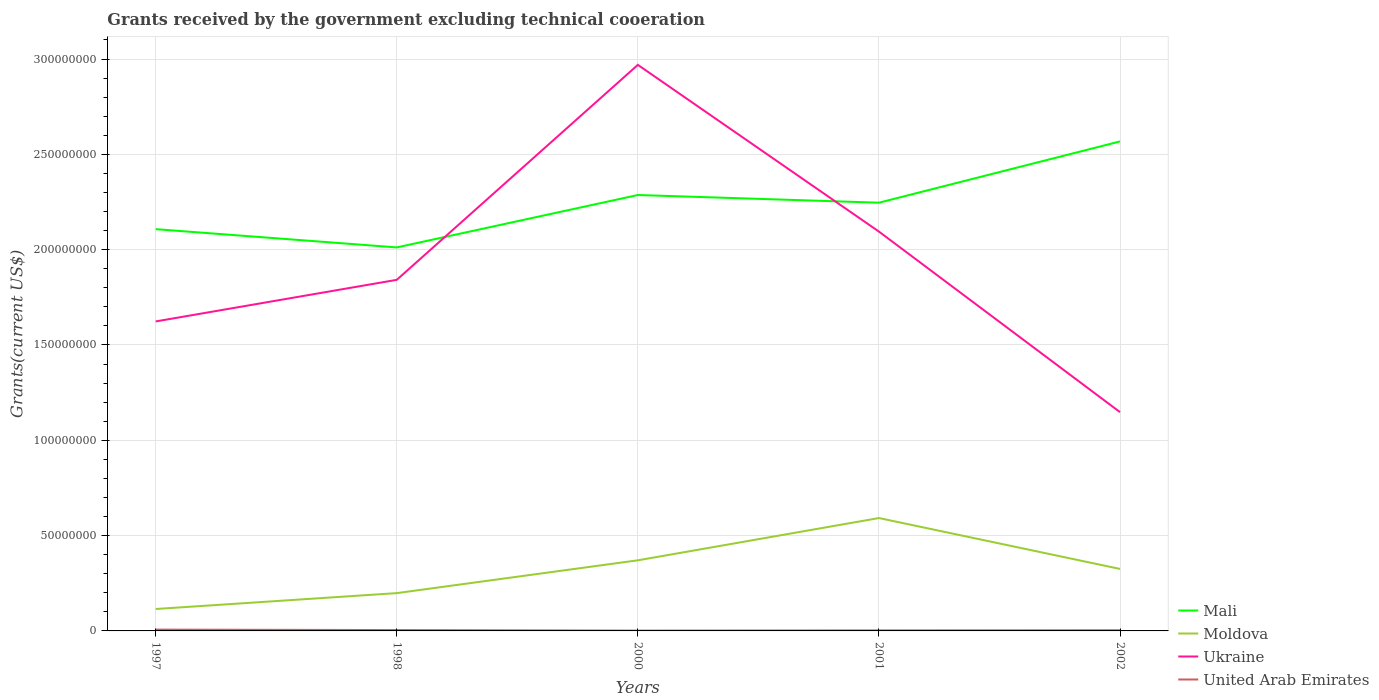Does the line corresponding to Ukraine intersect with the line corresponding to Mali?
Your response must be concise. Yes. Across all years, what is the maximum total grants received by the government in Mali?
Give a very brief answer. 2.01e+08. In which year was the total grants received by the government in Mali maximum?
Give a very brief answer. 1998. What is the total total grants received by the government in United Arab Emirates in the graph?
Your response must be concise. -1.10e+05. What is the difference between the highest and the second highest total grants received by the government in Mali?
Your answer should be compact. 5.56e+07. What is the difference between the highest and the lowest total grants received by the government in Moldova?
Provide a short and direct response. 3. How many years are there in the graph?
Make the answer very short. 5. What is the difference between two consecutive major ticks on the Y-axis?
Provide a succinct answer. 5.00e+07. Are the values on the major ticks of Y-axis written in scientific E-notation?
Provide a short and direct response. No. How many legend labels are there?
Your response must be concise. 4. What is the title of the graph?
Ensure brevity in your answer.  Grants received by the government excluding technical cooeration. What is the label or title of the X-axis?
Ensure brevity in your answer.  Years. What is the label or title of the Y-axis?
Make the answer very short. Grants(current US$). What is the Grants(current US$) of Mali in 1997?
Your answer should be very brief. 2.11e+08. What is the Grants(current US$) of Moldova in 1997?
Ensure brevity in your answer.  1.15e+07. What is the Grants(current US$) of Ukraine in 1997?
Make the answer very short. 1.62e+08. What is the Grants(current US$) of United Arab Emirates in 1997?
Keep it short and to the point. 6.90e+05. What is the Grants(current US$) of Mali in 1998?
Keep it short and to the point. 2.01e+08. What is the Grants(current US$) in Moldova in 1998?
Your answer should be compact. 1.98e+07. What is the Grants(current US$) of Ukraine in 1998?
Make the answer very short. 1.84e+08. What is the Grants(current US$) in Mali in 2000?
Provide a short and direct response. 2.29e+08. What is the Grants(current US$) in Moldova in 2000?
Ensure brevity in your answer.  3.70e+07. What is the Grants(current US$) of Ukraine in 2000?
Make the answer very short. 2.97e+08. What is the Grants(current US$) in Mali in 2001?
Your answer should be compact. 2.25e+08. What is the Grants(current US$) in Moldova in 2001?
Ensure brevity in your answer.  5.92e+07. What is the Grants(current US$) of Ukraine in 2001?
Your response must be concise. 2.09e+08. What is the Grants(current US$) of United Arab Emirates in 2001?
Keep it short and to the point. 2.80e+05. What is the Grants(current US$) of Mali in 2002?
Offer a very short reply. 2.57e+08. What is the Grants(current US$) in Moldova in 2002?
Make the answer very short. 3.25e+07. What is the Grants(current US$) in Ukraine in 2002?
Your answer should be very brief. 1.15e+08. Across all years, what is the maximum Grants(current US$) in Mali?
Provide a short and direct response. 2.57e+08. Across all years, what is the maximum Grants(current US$) of Moldova?
Give a very brief answer. 5.92e+07. Across all years, what is the maximum Grants(current US$) of Ukraine?
Your response must be concise. 2.97e+08. Across all years, what is the maximum Grants(current US$) of United Arab Emirates?
Keep it short and to the point. 6.90e+05. Across all years, what is the minimum Grants(current US$) in Mali?
Keep it short and to the point. 2.01e+08. Across all years, what is the minimum Grants(current US$) of Moldova?
Offer a terse response. 1.15e+07. Across all years, what is the minimum Grants(current US$) of Ukraine?
Offer a very short reply. 1.15e+08. What is the total Grants(current US$) in Mali in the graph?
Your response must be concise. 1.12e+09. What is the total Grants(current US$) of Moldova in the graph?
Ensure brevity in your answer.  1.60e+08. What is the total Grants(current US$) in Ukraine in the graph?
Make the answer very short. 9.68e+08. What is the total Grants(current US$) in United Arab Emirates in the graph?
Provide a short and direct response. 1.95e+06. What is the difference between the Grants(current US$) of Mali in 1997 and that in 1998?
Ensure brevity in your answer.  9.58e+06. What is the difference between the Grants(current US$) in Moldova in 1997 and that in 1998?
Provide a succinct answer. -8.33e+06. What is the difference between the Grants(current US$) of Ukraine in 1997 and that in 1998?
Your response must be concise. -2.18e+07. What is the difference between the Grants(current US$) of United Arab Emirates in 1997 and that in 1998?
Your answer should be very brief. 2.40e+05. What is the difference between the Grants(current US$) in Mali in 1997 and that in 2000?
Your answer should be very brief. -1.79e+07. What is the difference between the Grants(current US$) in Moldova in 1997 and that in 2000?
Offer a terse response. -2.55e+07. What is the difference between the Grants(current US$) in Ukraine in 1997 and that in 2000?
Make the answer very short. -1.35e+08. What is the difference between the Grants(current US$) of United Arab Emirates in 1997 and that in 2000?
Your answer should be compact. 5.20e+05. What is the difference between the Grants(current US$) of Mali in 1997 and that in 2001?
Provide a short and direct response. -1.39e+07. What is the difference between the Grants(current US$) in Moldova in 1997 and that in 2001?
Keep it short and to the point. -4.77e+07. What is the difference between the Grants(current US$) of Ukraine in 1997 and that in 2001?
Your answer should be compact. -4.71e+07. What is the difference between the Grants(current US$) in Mali in 1997 and that in 2002?
Keep it short and to the point. -4.60e+07. What is the difference between the Grants(current US$) in Moldova in 1997 and that in 2002?
Your response must be concise. -2.10e+07. What is the difference between the Grants(current US$) of Ukraine in 1997 and that in 2002?
Provide a short and direct response. 4.76e+07. What is the difference between the Grants(current US$) of Mali in 1998 and that in 2000?
Keep it short and to the point. -2.75e+07. What is the difference between the Grants(current US$) in Moldova in 1998 and that in 2000?
Keep it short and to the point. -1.72e+07. What is the difference between the Grants(current US$) of Ukraine in 1998 and that in 2000?
Keep it short and to the point. -1.13e+08. What is the difference between the Grants(current US$) in Mali in 1998 and that in 2001?
Provide a succinct answer. -2.35e+07. What is the difference between the Grants(current US$) of Moldova in 1998 and that in 2001?
Provide a short and direct response. -3.94e+07. What is the difference between the Grants(current US$) of Ukraine in 1998 and that in 2001?
Give a very brief answer. -2.53e+07. What is the difference between the Grants(current US$) of United Arab Emirates in 1998 and that in 2001?
Provide a succinct answer. 1.70e+05. What is the difference between the Grants(current US$) in Mali in 1998 and that in 2002?
Your answer should be compact. -5.56e+07. What is the difference between the Grants(current US$) of Moldova in 1998 and that in 2002?
Ensure brevity in your answer.  -1.27e+07. What is the difference between the Grants(current US$) in Ukraine in 1998 and that in 2002?
Your answer should be very brief. 6.94e+07. What is the difference between the Grants(current US$) in United Arab Emirates in 1998 and that in 2002?
Your response must be concise. 9.00e+04. What is the difference between the Grants(current US$) in Mali in 2000 and that in 2001?
Give a very brief answer. 4.03e+06. What is the difference between the Grants(current US$) of Moldova in 2000 and that in 2001?
Make the answer very short. -2.22e+07. What is the difference between the Grants(current US$) in Ukraine in 2000 and that in 2001?
Make the answer very short. 8.75e+07. What is the difference between the Grants(current US$) in Mali in 2000 and that in 2002?
Your response must be concise. -2.81e+07. What is the difference between the Grants(current US$) of Moldova in 2000 and that in 2002?
Offer a very short reply. 4.52e+06. What is the difference between the Grants(current US$) of Ukraine in 2000 and that in 2002?
Ensure brevity in your answer.  1.82e+08. What is the difference between the Grants(current US$) of Mali in 2001 and that in 2002?
Your answer should be compact. -3.21e+07. What is the difference between the Grants(current US$) in Moldova in 2001 and that in 2002?
Make the answer very short. 2.67e+07. What is the difference between the Grants(current US$) in Ukraine in 2001 and that in 2002?
Ensure brevity in your answer.  9.47e+07. What is the difference between the Grants(current US$) of United Arab Emirates in 2001 and that in 2002?
Provide a succinct answer. -8.00e+04. What is the difference between the Grants(current US$) in Mali in 1997 and the Grants(current US$) in Moldova in 1998?
Give a very brief answer. 1.91e+08. What is the difference between the Grants(current US$) of Mali in 1997 and the Grants(current US$) of Ukraine in 1998?
Offer a terse response. 2.66e+07. What is the difference between the Grants(current US$) of Mali in 1997 and the Grants(current US$) of United Arab Emirates in 1998?
Your answer should be very brief. 2.10e+08. What is the difference between the Grants(current US$) of Moldova in 1997 and the Grants(current US$) of Ukraine in 1998?
Provide a succinct answer. -1.73e+08. What is the difference between the Grants(current US$) of Moldova in 1997 and the Grants(current US$) of United Arab Emirates in 1998?
Ensure brevity in your answer.  1.10e+07. What is the difference between the Grants(current US$) of Ukraine in 1997 and the Grants(current US$) of United Arab Emirates in 1998?
Keep it short and to the point. 1.62e+08. What is the difference between the Grants(current US$) of Mali in 1997 and the Grants(current US$) of Moldova in 2000?
Your response must be concise. 1.74e+08. What is the difference between the Grants(current US$) of Mali in 1997 and the Grants(current US$) of Ukraine in 2000?
Your answer should be compact. -8.62e+07. What is the difference between the Grants(current US$) in Mali in 1997 and the Grants(current US$) in United Arab Emirates in 2000?
Your answer should be very brief. 2.11e+08. What is the difference between the Grants(current US$) of Moldova in 1997 and the Grants(current US$) of Ukraine in 2000?
Ensure brevity in your answer.  -2.85e+08. What is the difference between the Grants(current US$) in Moldova in 1997 and the Grants(current US$) in United Arab Emirates in 2000?
Your answer should be compact. 1.13e+07. What is the difference between the Grants(current US$) in Ukraine in 1997 and the Grants(current US$) in United Arab Emirates in 2000?
Keep it short and to the point. 1.62e+08. What is the difference between the Grants(current US$) of Mali in 1997 and the Grants(current US$) of Moldova in 2001?
Offer a very short reply. 1.52e+08. What is the difference between the Grants(current US$) in Mali in 1997 and the Grants(current US$) in Ukraine in 2001?
Offer a terse response. 1.28e+06. What is the difference between the Grants(current US$) of Mali in 1997 and the Grants(current US$) of United Arab Emirates in 2001?
Your answer should be very brief. 2.10e+08. What is the difference between the Grants(current US$) in Moldova in 1997 and the Grants(current US$) in Ukraine in 2001?
Your answer should be very brief. -1.98e+08. What is the difference between the Grants(current US$) in Moldova in 1997 and the Grants(current US$) in United Arab Emirates in 2001?
Make the answer very short. 1.12e+07. What is the difference between the Grants(current US$) of Ukraine in 1997 and the Grants(current US$) of United Arab Emirates in 2001?
Ensure brevity in your answer.  1.62e+08. What is the difference between the Grants(current US$) of Mali in 1997 and the Grants(current US$) of Moldova in 2002?
Your answer should be compact. 1.78e+08. What is the difference between the Grants(current US$) in Mali in 1997 and the Grants(current US$) in Ukraine in 2002?
Keep it short and to the point. 9.60e+07. What is the difference between the Grants(current US$) of Mali in 1997 and the Grants(current US$) of United Arab Emirates in 2002?
Give a very brief answer. 2.10e+08. What is the difference between the Grants(current US$) in Moldova in 1997 and the Grants(current US$) in Ukraine in 2002?
Your response must be concise. -1.03e+08. What is the difference between the Grants(current US$) in Moldova in 1997 and the Grants(current US$) in United Arab Emirates in 2002?
Provide a succinct answer. 1.11e+07. What is the difference between the Grants(current US$) in Ukraine in 1997 and the Grants(current US$) in United Arab Emirates in 2002?
Your response must be concise. 1.62e+08. What is the difference between the Grants(current US$) of Mali in 1998 and the Grants(current US$) of Moldova in 2000?
Provide a succinct answer. 1.64e+08. What is the difference between the Grants(current US$) of Mali in 1998 and the Grants(current US$) of Ukraine in 2000?
Make the answer very short. -9.58e+07. What is the difference between the Grants(current US$) in Mali in 1998 and the Grants(current US$) in United Arab Emirates in 2000?
Ensure brevity in your answer.  2.01e+08. What is the difference between the Grants(current US$) of Moldova in 1998 and the Grants(current US$) of Ukraine in 2000?
Give a very brief answer. -2.77e+08. What is the difference between the Grants(current US$) in Moldova in 1998 and the Grants(current US$) in United Arab Emirates in 2000?
Offer a terse response. 1.97e+07. What is the difference between the Grants(current US$) of Ukraine in 1998 and the Grants(current US$) of United Arab Emirates in 2000?
Keep it short and to the point. 1.84e+08. What is the difference between the Grants(current US$) of Mali in 1998 and the Grants(current US$) of Moldova in 2001?
Offer a terse response. 1.42e+08. What is the difference between the Grants(current US$) of Mali in 1998 and the Grants(current US$) of Ukraine in 2001?
Make the answer very short. -8.30e+06. What is the difference between the Grants(current US$) in Mali in 1998 and the Grants(current US$) in United Arab Emirates in 2001?
Your answer should be very brief. 2.01e+08. What is the difference between the Grants(current US$) of Moldova in 1998 and the Grants(current US$) of Ukraine in 2001?
Provide a short and direct response. -1.90e+08. What is the difference between the Grants(current US$) of Moldova in 1998 and the Grants(current US$) of United Arab Emirates in 2001?
Provide a succinct answer. 1.96e+07. What is the difference between the Grants(current US$) in Ukraine in 1998 and the Grants(current US$) in United Arab Emirates in 2001?
Keep it short and to the point. 1.84e+08. What is the difference between the Grants(current US$) in Mali in 1998 and the Grants(current US$) in Moldova in 2002?
Give a very brief answer. 1.69e+08. What is the difference between the Grants(current US$) in Mali in 1998 and the Grants(current US$) in Ukraine in 2002?
Give a very brief answer. 8.64e+07. What is the difference between the Grants(current US$) in Mali in 1998 and the Grants(current US$) in United Arab Emirates in 2002?
Provide a succinct answer. 2.01e+08. What is the difference between the Grants(current US$) of Moldova in 1998 and the Grants(current US$) of Ukraine in 2002?
Make the answer very short. -9.49e+07. What is the difference between the Grants(current US$) in Moldova in 1998 and the Grants(current US$) in United Arab Emirates in 2002?
Your answer should be very brief. 1.95e+07. What is the difference between the Grants(current US$) in Ukraine in 1998 and the Grants(current US$) in United Arab Emirates in 2002?
Your answer should be compact. 1.84e+08. What is the difference between the Grants(current US$) in Mali in 2000 and the Grants(current US$) in Moldova in 2001?
Your answer should be very brief. 1.69e+08. What is the difference between the Grants(current US$) in Mali in 2000 and the Grants(current US$) in Ukraine in 2001?
Ensure brevity in your answer.  1.92e+07. What is the difference between the Grants(current US$) in Mali in 2000 and the Grants(current US$) in United Arab Emirates in 2001?
Your answer should be very brief. 2.28e+08. What is the difference between the Grants(current US$) of Moldova in 2000 and the Grants(current US$) of Ukraine in 2001?
Make the answer very short. -1.72e+08. What is the difference between the Grants(current US$) of Moldova in 2000 and the Grants(current US$) of United Arab Emirates in 2001?
Offer a very short reply. 3.68e+07. What is the difference between the Grants(current US$) in Ukraine in 2000 and the Grants(current US$) in United Arab Emirates in 2001?
Your answer should be very brief. 2.97e+08. What is the difference between the Grants(current US$) of Mali in 2000 and the Grants(current US$) of Moldova in 2002?
Your answer should be compact. 1.96e+08. What is the difference between the Grants(current US$) in Mali in 2000 and the Grants(current US$) in Ukraine in 2002?
Your response must be concise. 1.14e+08. What is the difference between the Grants(current US$) of Mali in 2000 and the Grants(current US$) of United Arab Emirates in 2002?
Give a very brief answer. 2.28e+08. What is the difference between the Grants(current US$) in Moldova in 2000 and the Grants(current US$) in Ukraine in 2002?
Offer a terse response. -7.77e+07. What is the difference between the Grants(current US$) in Moldova in 2000 and the Grants(current US$) in United Arab Emirates in 2002?
Ensure brevity in your answer.  3.67e+07. What is the difference between the Grants(current US$) in Ukraine in 2000 and the Grants(current US$) in United Arab Emirates in 2002?
Ensure brevity in your answer.  2.97e+08. What is the difference between the Grants(current US$) in Mali in 2001 and the Grants(current US$) in Moldova in 2002?
Provide a succinct answer. 1.92e+08. What is the difference between the Grants(current US$) in Mali in 2001 and the Grants(current US$) in Ukraine in 2002?
Your answer should be very brief. 1.10e+08. What is the difference between the Grants(current US$) in Mali in 2001 and the Grants(current US$) in United Arab Emirates in 2002?
Keep it short and to the point. 2.24e+08. What is the difference between the Grants(current US$) of Moldova in 2001 and the Grants(current US$) of Ukraine in 2002?
Offer a very short reply. -5.55e+07. What is the difference between the Grants(current US$) of Moldova in 2001 and the Grants(current US$) of United Arab Emirates in 2002?
Offer a terse response. 5.88e+07. What is the difference between the Grants(current US$) in Ukraine in 2001 and the Grants(current US$) in United Arab Emirates in 2002?
Make the answer very short. 2.09e+08. What is the average Grants(current US$) in Mali per year?
Provide a short and direct response. 2.24e+08. What is the average Grants(current US$) in Moldova per year?
Provide a short and direct response. 3.20e+07. What is the average Grants(current US$) in Ukraine per year?
Your response must be concise. 1.94e+08. What is the average Grants(current US$) of United Arab Emirates per year?
Make the answer very short. 3.90e+05. In the year 1997, what is the difference between the Grants(current US$) of Mali and Grants(current US$) of Moldova?
Offer a very short reply. 1.99e+08. In the year 1997, what is the difference between the Grants(current US$) of Mali and Grants(current US$) of Ukraine?
Provide a succinct answer. 4.84e+07. In the year 1997, what is the difference between the Grants(current US$) of Mali and Grants(current US$) of United Arab Emirates?
Provide a short and direct response. 2.10e+08. In the year 1997, what is the difference between the Grants(current US$) in Moldova and Grants(current US$) in Ukraine?
Give a very brief answer. -1.51e+08. In the year 1997, what is the difference between the Grants(current US$) in Moldova and Grants(current US$) in United Arab Emirates?
Offer a very short reply. 1.08e+07. In the year 1997, what is the difference between the Grants(current US$) of Ukraine and Grants(current US$) of United Arab Emirates?
Provide a succinct answer. 1.62e+08. In the year 1998, what is the difference between the Grants(current US$) in Mali and Grants(current US$) in Moldova?
Your answer should be compact. 1.81e+08. In the year 1998, what is the difference between the Grants(current US$) in Mali and Grants(current US$) in Ukraine?
Your answer should be compact. 1.70e+07. In the year 1998, what is the difference between the Grants(current US$) of Mali and Grants(current US$) of United Arab Emirates?
Your answer should be very brief. 2.01e+08. In the year 1998, what is the difference between the Grants(current US$) in Moldova and Grants(current US$) in Ukraine?
Provide a succinct answer. -1.64e+08. In the year 1998, what is the difference between the Grants(current US$) of Moldova and Grants(current US$) of United Arab Emirates?
Offer a terse response. 1.94e+07. In the year 1998, what is the difference between the Grants(current US$) in Ukraine and Grants(current US$) in United Arab Emirates?
Your response must be concise. 1.84e+08. In the year 2000, what is the difference between the Grants(current US$) of Mali and Grants(current US$) of Moldova?
Your answer should be very brief. 1.92e+08. In the year 2000, what is the difference between the Grants(current US$) in Mali and Grants(current US$) in Ukraine?
Your answer should be compact. -6.83e+07. In the year 2000, what is the difference between the Grants(current US$) in Mali and Grants(current US$) in United Arab Emirates?
Offer a terse response. 2.28e+08. In the year 2000, what is the difference between the Grants(current US$) of Moldova and Grants(current US$) of Ukraine?
Offer a terse response. -2.60e+08. In the year 2000, what is the difference between the Grants(current US$) in Moldova and Grants(current US$) in United Arab Emirates?
Your answer should be very brief. 3.69e+07. In the year 2000, what is the difference between the Grants(current US$) in Ukraine and Grants(current US$) in United Arab Emirates?
Keep it short and to the point. 2.97e+08. In the year 2001, what is the difference between the Grants(current US$) of Mali and Grants(current US$) of Moldova?
Your answer should be very brief. 1.65e+08. In the year 2001, what is the difference between the Grants(current US$) of Mali and Grants(current US$) of Ukraine?
Provide a short and direct response. 1.52e+07. In the year 2001, what is the difference between the Grants(current US$) in Mali and Grants(current US$) in United Arab Emirates?
Provide a short and direct response. 2.24e+08. In the year 2001, what is the difference between the Grants(current US$) of Moldova and Grants(current US$) of Ukraine?
Ensure brevity in your answer.  -1.50e+08. In the year 2001, what is the difference between the Grants(current US$) of Moldova and Grants(current US$) of United Arab Emirates?
Give a very brief answer. 5.89e+07. In the year 2001, what is the difference between the Grants(current US$) in Ukraine and Grants(current US$) in United Arab Emirates?
Offer a terse response. 2.09e+08. In the year 2002, what is the difference between the Grants(current US$) of Mali and Grants(current US$) of Moldova?
Give a very brief answer. 2.24e+08. In the year 2002, what is the difference between the Grants(current US$) of Mali and Grants(current US$) of Ukraine?
Your response must be concise. 1.42e+08. In the year 2002, what is the difference between the Grants(current US$) in Mali and Grants(current US$) in United Arab Emirates?
Your answer should be compact. 2.56e+08. In the year 2002, what is the difference between the Grants(current US$) of Moldova and Grants(current US$) of Ukraine?
Provide a short and direct response. -8.22e+07. In the year 2002, what is the difference between the Grants(current US$) of Moldova and Grants(current US$) of United Arab Emirates?
Keep it short and to the point. 3.22e+07. In the year 2002, what is the difference between the Grants(current US$) in Ukraine and Grants(current US$) in United Arab Emirates?
Your answer should be very brief. 1.14e+08. What is the ratio of the Grants(current US$) in Mali in 1997 to that in 1998?
Keep it short and to the point. 1.05. What is the ratio of the Grants(current US$) in Moldova in 1997 to that in 1998?
Your answer should be very brief. 0.58. What is the ratio of the Grants(current US$) in Ukraine in 1997 to that in 1998?
Your answer should be compact. 0.88. What is the ratio of the Grants(current US$) in United Arab Emirates in 1997 to that in 1998?
Keep it short and to the point. 1.53. What is the ratio of the Grants(current US$) of Mali in 1997 to that in 2000?
Keep it short and to the point. 0.92. What is the ratio of the Grants(current US$) of Moldova in 1997 to that in 2000?
Provide a short and direct response. 0.31. What is the ratio of the Grants(current US$) in Ukraine in 1997 to that in 2000?
Keep it short and to the point. 0.55. What is the ratio of the Grants(current US$) of United Arab Emirates in 1997 to that in 2000?
Give a very brief answer. 4.06. What is the ratio of the Grants(current US$) of Mali in 1997 to that in 2001?
Offer a very short reply. 0.94. What is the ratio of the Grants(current US$) in Moldova in 1997 to that in 2001?
Your answer should be very brief. 0.19. What is the ratio of the Grants(current US$) in Ukraine in 1997 to that in 2001?
Keep it short and to the point. 0.78. What is the ratio of the Grants(current US$) of United Arab Emirates in 1997 to that in 2001?
Your answer should be compact. 2.46. What is the ratio of the Grants(current US$) in Mali in 1997 to that in 2002?
Make the answer very short. 0.82. What is the ratio of the Grants(current US$) of Moldova in 1997 to that in 2002?
Your response must be concise. 0.35. What is the ratio of the Grants(current US$) of Ukraine in 1997 to that in 2002?
Provide a short and direct response. 1.41. What is the ratio of the Grants(current US$) in United Arab Emirates in 1997 to that in 2002?
Provide a short and direct response. 1.92. What is the ratio of the Grants(current US$) of Mali in 1998 to that in 2000?
Make the answer very short. 0.88. What is the ratio of the Grants(current US$) of Moldova in 1998 to that in 2000?
Your answer should be compact. 0.54. What is the ratio of the Grants(current US$) of Ukraine in 1998 to that in 2000?
Your answer should be compact. 0.62. What is the ratio of the Grants(current US$) of United Arab Emirates in 1998 to that in 2000?
Your answer should be compact. 2.65. What is the ratio of the Grants(current US$) of Mali in 1998 to that in 2001?
Offer a terse response. 0.9. What is the ratio of the Grants(current US$) in Moldova in 1998 to that in 2001?
Give a very brief answer. 0.33. What is the ratio of the Grants(current US$) of Ukraine in 1998 to that in 2001?
Give a very brief answer. 0.88. What is the ratio of the Grants(current US$) in United Arab Emirates in 1998 to that in 2001?
Offer a terse response. 1.61. What is the ratio of the Grants(current US$) in Mali in 1998 to that in 2002?
Make the answer very short. 0.78. What is the ratio of the Grants(current US$) in Moldova in 1998 to that in 2002?
Ensure brevity in your answer.  0.61. What is the ratio of the Grants(current US$) in Ukraine in 1998 to that in 2002?
Your answer should be compact. 1.6. What is the ratio of the Grants(current US$) in Mali in 2000 to that in 2001?
Offer a terse response. 1.02. What is the ratio of the Grants(current US$) of Moldova in 2000 to that in 2001?
Give a very brief answer. 0.63. What is the ratio of the Grants(current US$) of Ukraine in 2000 to that in 2001?
Your answer should be compact. 1.42. What is the ratio of the Grants(current US$) in United Arab Emirates in 2000 to that in 2001?
Your answer should be very brief. 0.61. What is the ratio of the Grants(current US$) in Mali in 2000 to that in 2002?
Keep it short and to the point. 0.89. What is the ratio of the Grants(current US$) of Moldova in 2000 to that in 2002?
Your response must be concise. 1.14. What is the ratio of the Grants(current US$) of Ukraine in 2000 to that in 2002?
Your answer should be compact. 2.59. What is the ratio of the Grants(current US$) in United Arab Emirates in 2000 to that in 2002?
Make the answer very short. 0.47. What is the ratio of the Grants(current US$) in Mali in 2001 to that in 2002?
Your answer should be compact. 0.87. What is the ratio of the Grants(current US$) of Moldova in 2001 to that in 2002?
Provide a short and direct response. 1.82. What is the ratio of the Grants(current US$) in Ukraine in 2001 to that in 2002?
Offer a very short reply. 1.83. What is the ratio of the Grants(current US$) in United Arab Emirates in 2001 to that in 2002?
Your response must be concise. 0.78. What is the difference between the highest and the second highest Grants(current US$) in Mali?
Offer a very short reply. 2.81e+07. What is the difference between the highest and the second highest Grants(current US$) of Moldova?
Your answer should be compact. 2.22e+07. What is the difference between the highest and the second highest Grants(current US$) in Ukraine?
Ensure brevity in your answer.  8.75e+07. What is the difference between the highest and the lowest Grants(current US$) in Mali?
Offer a very short reply. 5.56e+07. What is the difference between the highest and the lowest Grants(current US$) of Moldova?
Your answer should be compact. 4.77e+07. What is the difference between the highest and the lowest Grants(current US$) in Ukraine?
Provide a succinct answer. 1.82e+08. What is the difference between the highest and the lowest Grants(current US$) of United Arab Emirates?
Your answer should be very brief. 5.20e+05. 